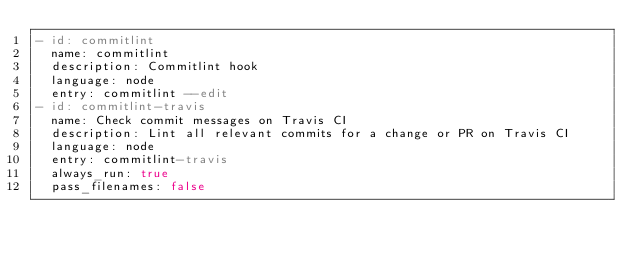Convert code to text. <code><loc_0><loc_0><loc_500><loc_500><_YAML_>- id: commitlint
  name: commitlint
  description: Commitlint hook
  language: node
  entry: commitlint --edit
- id: commitlint-travis
  name: Check commit messages on Travis CI
  description: Lint all relevant commits for a change or PR on Travis CI
  language: node
  entry: commitlint-travis
  always_run: true
  pass_filenames: false
</code> 